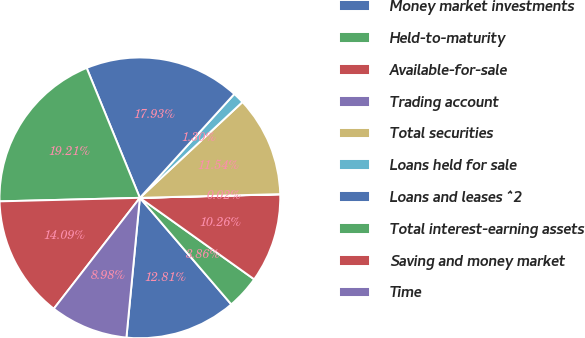<chart> <loc_0><loc_0><loc_500><loc_500><pie_chart><fcel>Money market investments<fcel>Held-to-maturity<fcel>Available-for-sale<fcel>Trading account<fcel>Total securities<fcel>Loans held for sale<fcel>Loans and leases ^2<fcel>Total interest-earning assets<fcel>Saving and money market<fcel>Time<nl><fcel>12.82%<fcel>3.86%<fcel>10.26%<fcel>0.02%<fcel>11.54%<fcel>1.3%<fcel>17.94%<fcel>19.22%<fcel>14.1%<fcel>8.98%<nl></chart> 